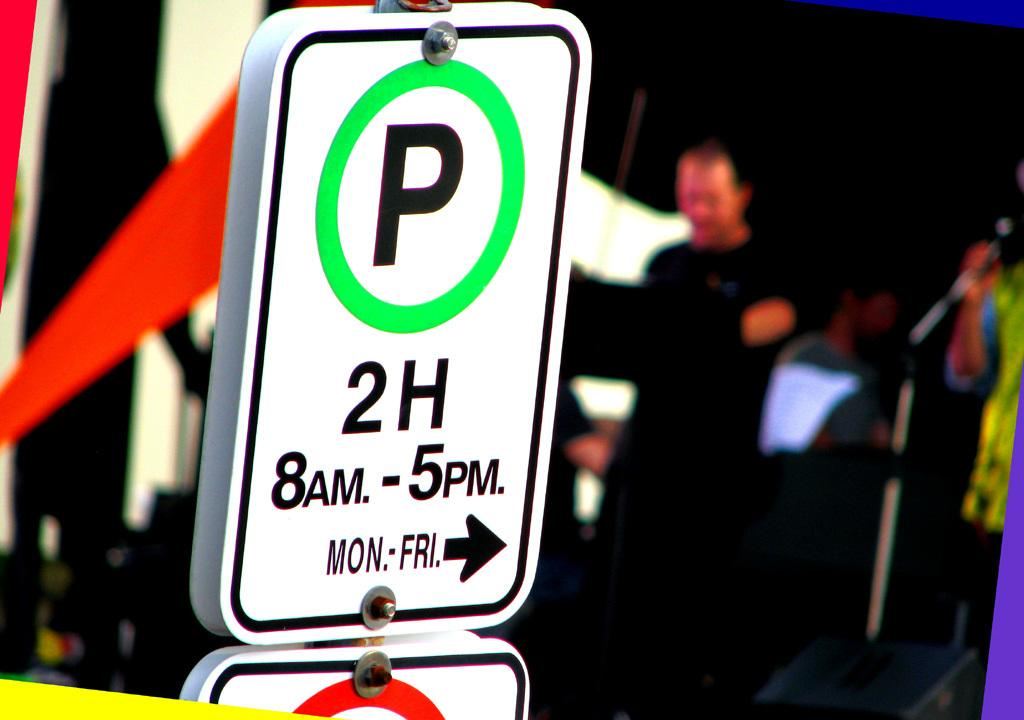Provide a one-sentence caption for the provided image. A parking sign advertising the 2 hour parking. 